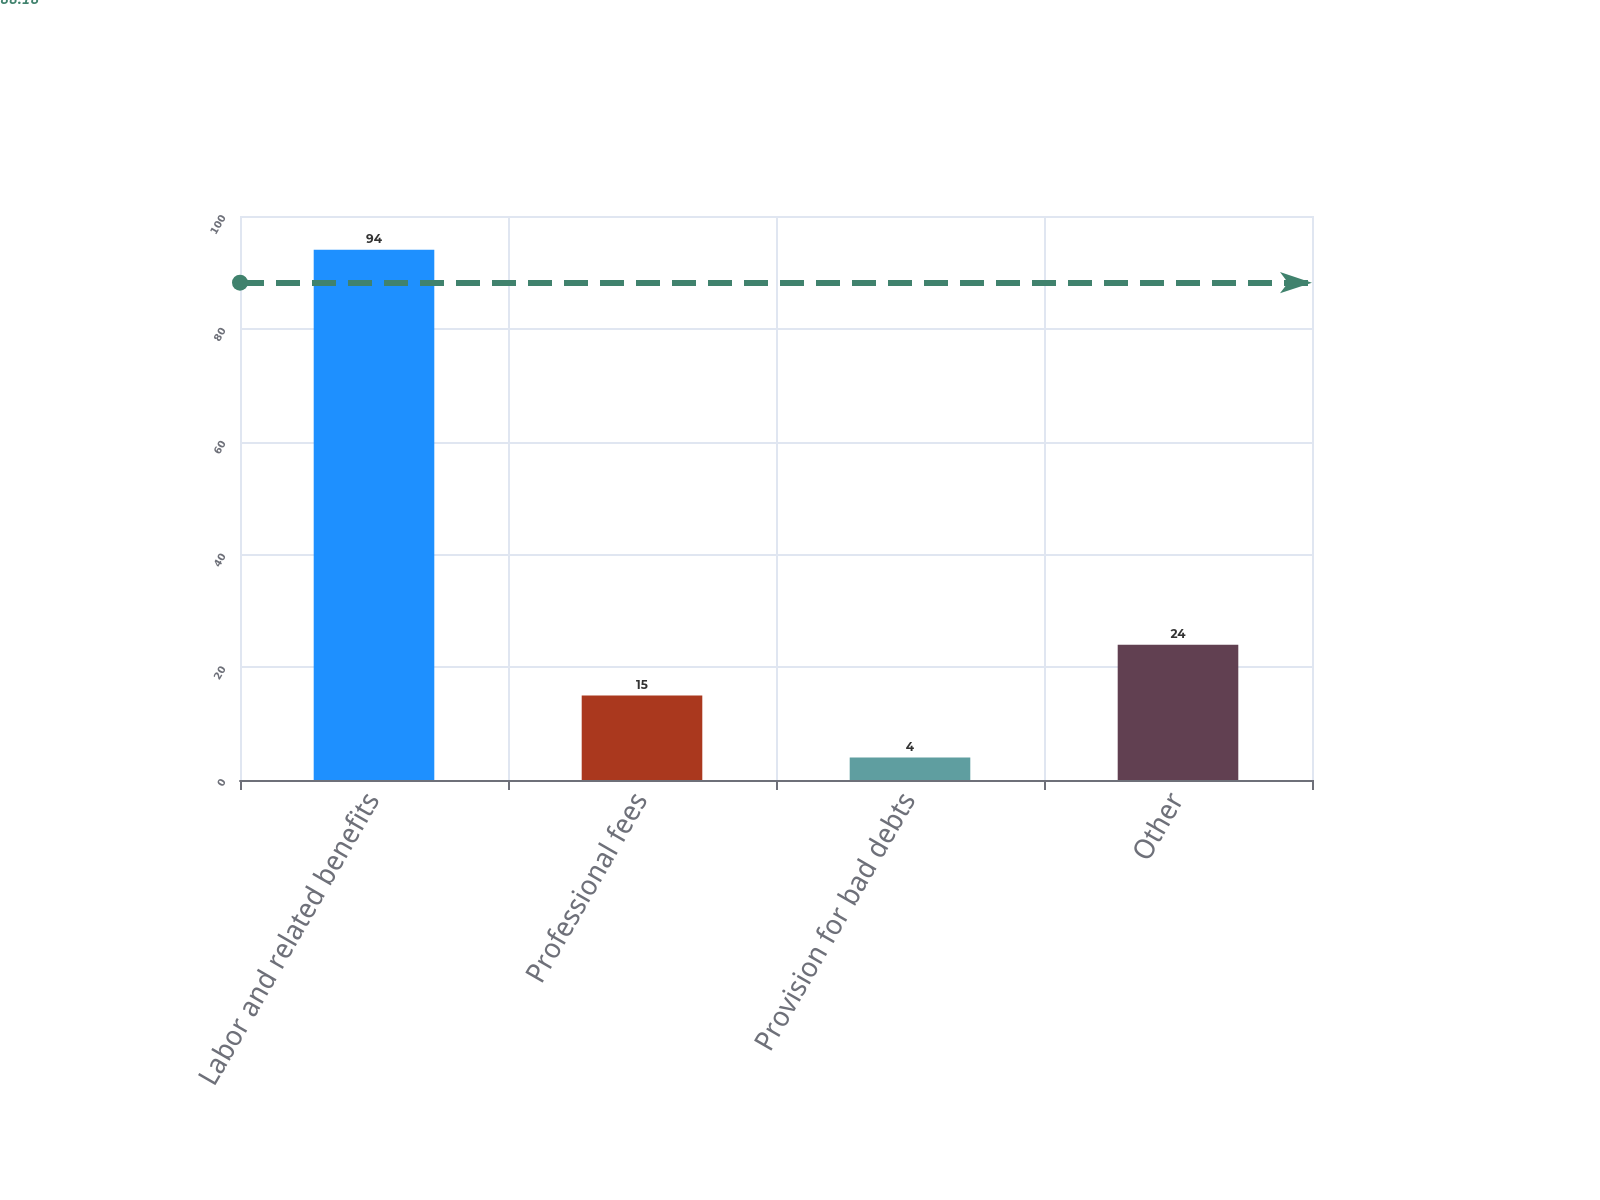Convert chart. <chart><loc_0><loc_0><loc_500><loc_500><bar_chart><fcel>Labor and related benefits<fcel>Professional fees<fcel>Provision for bad debts<fcel>Other<nl><fcel>94<fcel>15<fcel>4<fcel>24<nl></chart> 